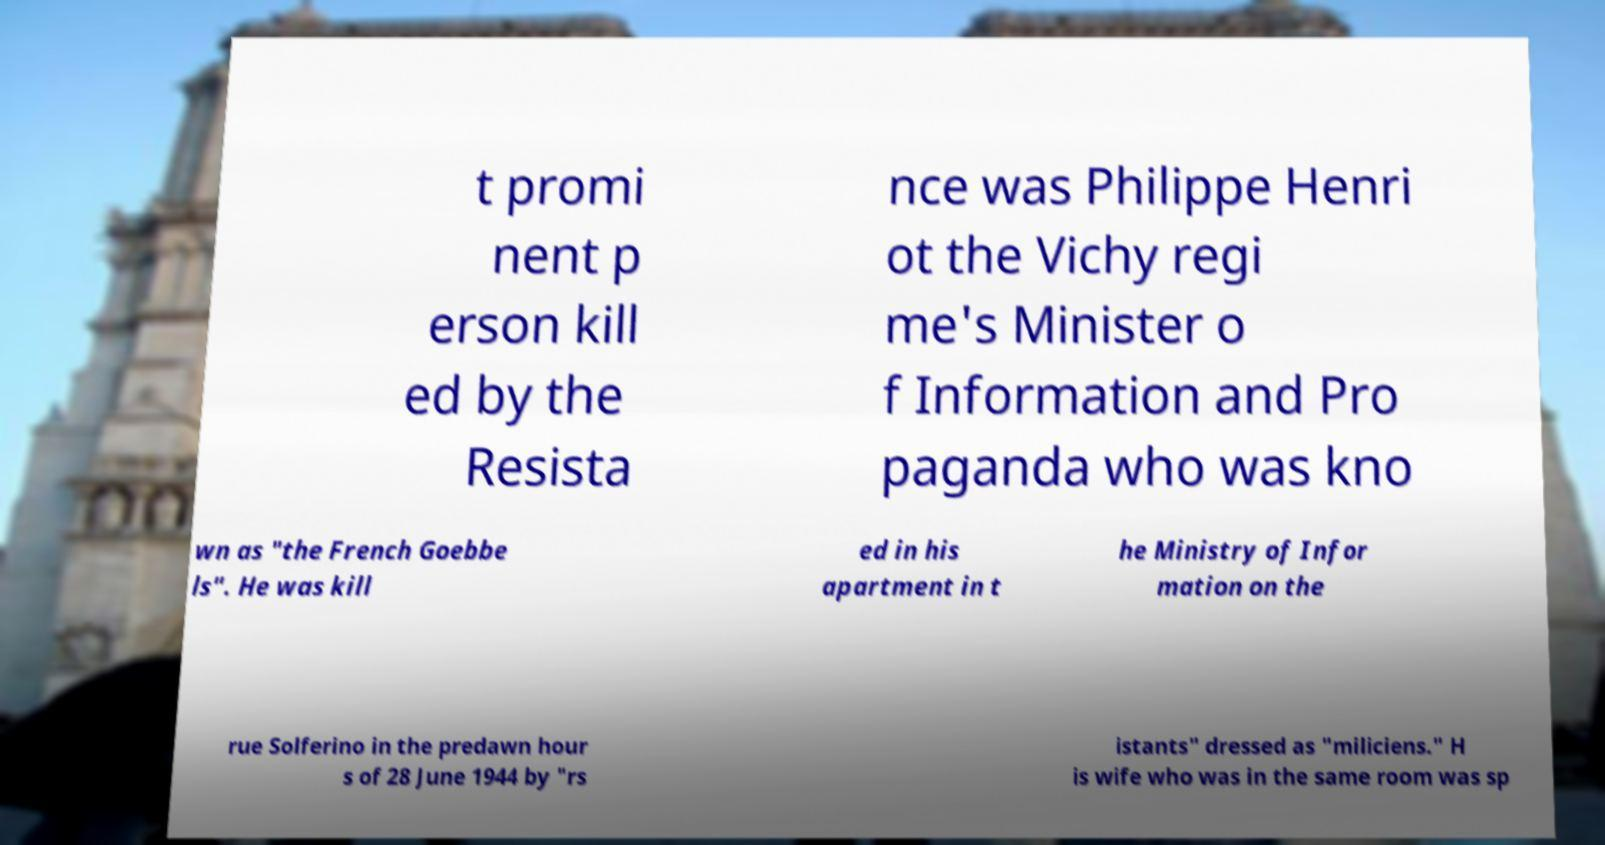There's text embedded in this image that I need extracted. Can you transcribe it verbatim? t promi nent p erson kill ed by the Resista nce was Philippe Henri ot the Vichy regi me's Minister o f Information and Pro paganda who was kno wn as "the French Goebbe ls". He was kill ed in his apartment in t he Ministry of Infor mation on the rue Solferino in the predawn hour s of 28 June 1944 by "rs istants" dressed as "miliciens." H is wife who was in the same room was sp 